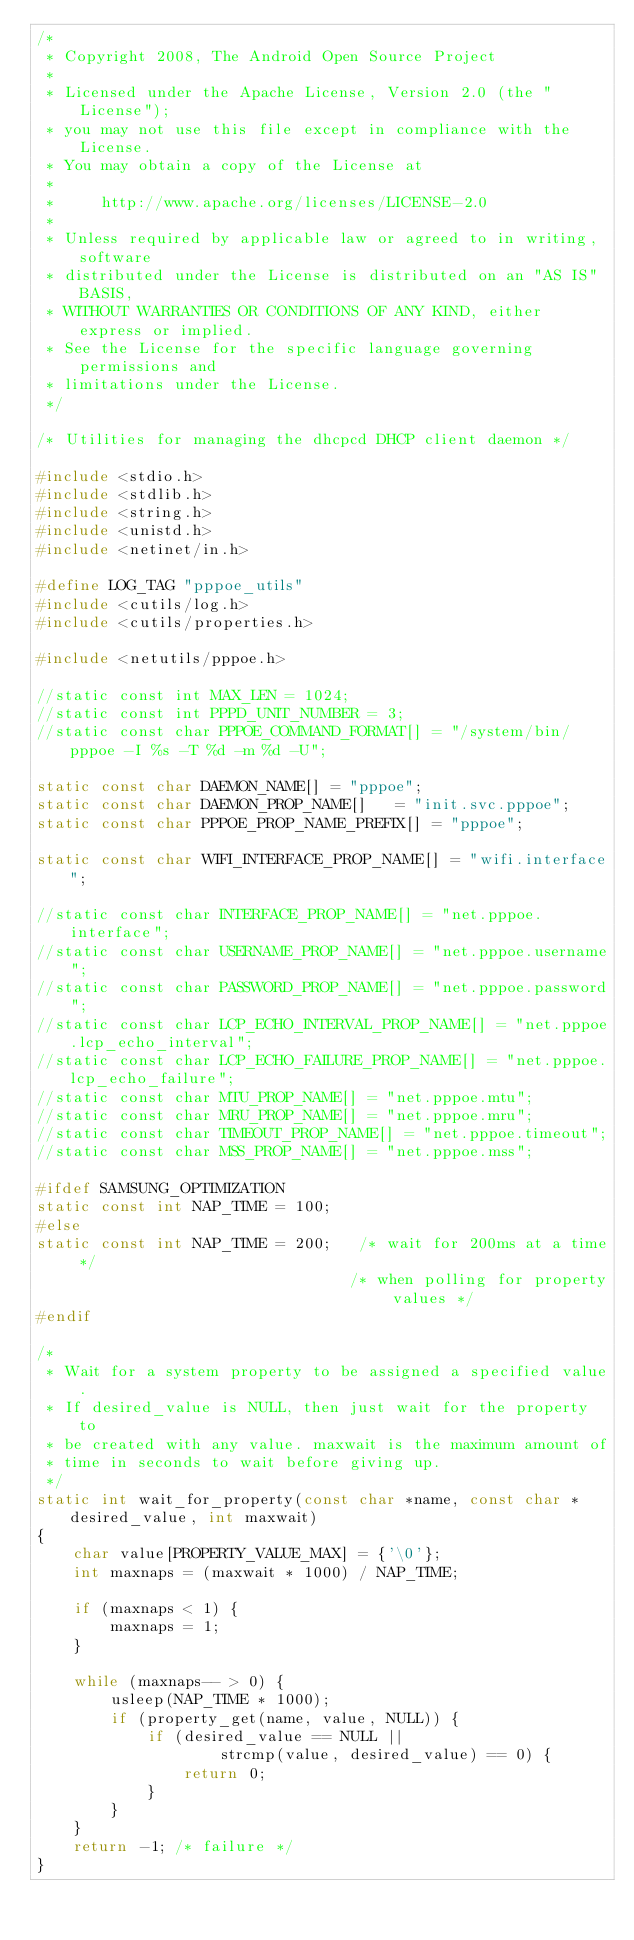Convert code to text. <code><loc_0><loc_0><loc_500><loc_500><_C_>/*
 * Copyright 2008, The Android Open Source Project
 *
 * Licensed under the Apache License, Version 2.0 (the "License");
 * you may not use this file except in compliance with the License.
 * You may obtain a copy of the License at
 *
 *     http://www.apache.org/licenses/LICENSE-2.0
 *
 * Unless required by applicable law or agreed to in writing, software
 * distributed under the License is distributed on an "AS IS" BASIS,
 * WITHOUT WARRANTIES OR CONDITIONS OF ANY KIND, either express or implied.
 * See the License for the specific language governing permissions and
 * limitations under the License.
 */

/* Utilities for managing the dhcpcd DHCP client daemon */

#include <stdio.h>
#include <stdlib.h>
#include <string.h>
#include <unistd.h>
#include <netinet/in.h>

#define LOG_TAG "pppoe_utils"
#include <cutils/log.h>
#include <cutils/properties.h>

#include <netutils/pppoe.h>

//static const int MAX_LEN = 1024;
//static const int PPPD_UNIT_NUMBER = 3;
//static const char PPPOE_COMMAND_FORMAT[] = "/system/bin/pppoe -I %s -T %d -m %d -U";

static const char DAEMON_NAME[] = "pppoe";
static const char DAEMON_PROP_NAME[]   = "init.svc.pppoe";
static const char PPPOE_PROP_NAME_PREFIX[] = "pppoe";

static const char WIFI_INTERFACE_PROP_NAME[] = "wifi.interface";

//static const char INTERFACE_PROP_NAME[] = "net.pppoe.interface";
//static const char USERNAME_PROP_NAME[] = "net.pppoe.username";
//static const char PASSWORD_PROP_NAME[] = "net.pppoe.password";
//static const char LCP_ECHO_INTERVAL_PROP_NAME[] = "net.pppoe.lcp_echo_interval";
//static const char LCP_ECHO_FAILURE_PROP_NAME[] = "net.pppoe.lcp_echo_failure";
//static const char MTU_PROP_NAME[] = "net.pppoe.mtu";
//static const char MRU_PROP_NAME[] = "net.pppoe.mru";
//static const char TIMEOUT_PROP_NAME[] = "net.pppoe.timeout";
//static const char MSS_PROP_NAME[] = "net.pppoe.mss";

#ifdef SAMSUNG_OPTIMIZATION
static const int NAP_TIME = 100;
#else
static const int NAP_TIME = 200;   /* wait for 200ms at a time */
                                  /* when polling for property values */
#endif

/*
 * Wait for a system property to be assigned a specified value.
 * If desired_value is NULL, then just wait for the property to
 * be created with any value. maxwait is the maximum amount of
 * time in seconds to wait before giving up.
 */
static int wait_for_property(const char *name, const char *desired_value, int maxwait)
{
    char value[PROPERTY_VALUE_MAX] = {'\0'};
    int maxnaps = (maxwait * 1000) / NAP_TIME;

    if (maxnaps < 1) {
        maxnaps = 1;
    }

    while (maxnaps-- > 0) {
        usleep(NAP_TIME * 1000);
        if (property_get(name, value, NULL)) {
            if (desired_value == NULL ||
                    strcmp(value, desired_value) == 0) {
                return 0;
            }
        }
    }
    return -1; /* failure */
}
</code> 